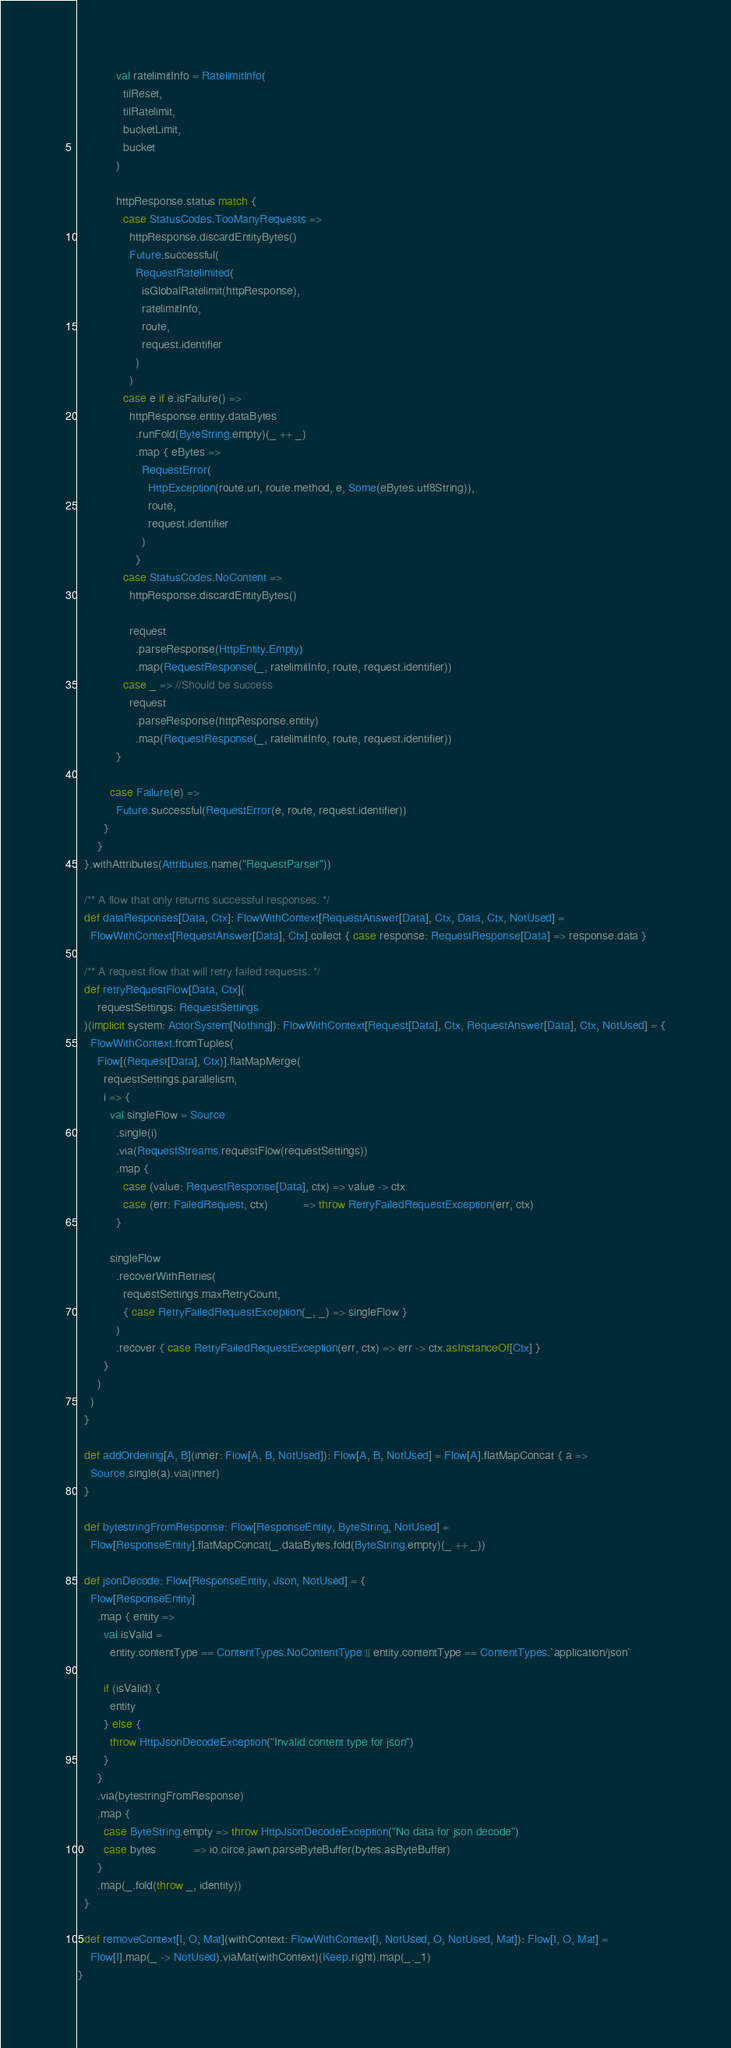<code> <loc_0><loc_0><loc_500><loc_500><_Scala_>
            val ratelimitInfo = RatelimitInfo(
              tilReset,
              tilRatelimit,
              bucketLimit,
              bucket
            )

            httpResponse.status match {
              case StatusCodes.TooManyRequests =>
                httpResponse.discardEntityBytes()
                Future.successful(
                  RequestRatelimited(
                    isGlobalRatelimit(httpResponse),
                    ratelimitInfo,
                    route,
                    request.identifier
                  )
                )
              case e if e.isFailure() =>
                httpResponse.entity.dataBytes
                  .runFold(ByteString.empty)(_ ++ _)
                  .map { eBytes =>
                    RequestError(
                      HttpException(route.uri, route.method, e, Some(eBytes.utf8String)),
                      route,
                      request.identifier
                    )
                  }
              case StatusCodes.NoContent =>
                httpResponse.discardEntityBytes()

                request
                  .parseResponse(HttpEntity.Empty)
                  .map(RequestResponse(_, ratelimitInfo, route, request.identifier))
              case _ => //Should be success
                request
                  .parseResponse(httpResponse.entity)
                  .map(RequestResponse(_, ratelimitInfo, route, request.identifier))
            }

          case Failure(e) =>
            Future.successful(RequestError(e, route, request.identifier))
        }
      }
  }.withAttributes(Attributes.name("RequestParser"))

  /** A flow that only returns successful responses. */
  def dataResponses[Data, Ctx]: FlowWithContext[RequestAnswer[Data], Ctx, Data, Ctx, NotUsed] =
    FlowWithContext[RequestAnswer[Data], Ctx].collect { case response: RequestResponse[Data] => response.data }

  /** A request flow that will retry failed requests. */
  def retryRequestFlow[Data, Ctx](
      requestSettings: RequestSettings
  )(implicit system: ActorSystem[Nothing]): FlowWithContext[Request[Data], Ctx, RequestAnswer[Data], Ctx, NotUsed] = {
    FlowWithContext.fromTuples(
      Flow[(Request[Data], Ctx)].flatMapMerge(
        requestSettings.parallelism,
        i => {
          val singleFlow = Source
            .single(i)
            .via(RequestStreams.requestFlow(requestSettings))
            .map {
              case (value: RequestResponse[Data], ctx) => value -> ctx
              case (err: FailedRequest, ctx)           => throw RetryFailedRequestException(err, ctx)
            }

          singleFlow
            .recoverWithRetries(
              requestSettings.maxRetryCount,
              { case RetryFailedRequestException(_, _) => singleFlow }
            )
            .recover { case RetryFailedRequestException(err, ctx) => err -> ctx.asInstanceOf[Ctx] }
        }
      )
    )
  }

  def addOrdering[A, B](inner: Flow[A, B, NotUsed]): Flow[A, B, NotUsed] = Flow[A].flatMapConcat { a =>
    Source.single(a).via(inner)
  }

  def bytestringFromResponse: Flow[ResponseEntity, ByteString, NotUsed] =
    Flow[ResponseEntity].flatMapConcat(_.dataBytes.fold(ByteString.empty)(_ ++ _))

  def jsonDecode: Flow[ResponseEntity, Json, NotUsed] = {
    Flow[ResponseEntity]
      .map { entity =>
        val isValid =
          entity.contentType == ContentTypes.NoContentType || entity.contentType == ContentTypes.`application/json`

        if (isValid) {
          entity
        } else {
          throw HttpJsonDecodeException("Invalid content type for json")
        }
      }
      .via(bytestringFromResponse)
      .map {
        case ByteString.empty => throw HttpJsonDecodeException("No data for json decode")
        case bytes            => io.circe.jawn.parseByteBuffer(bytes.asByteBuffer)
      }
      .map(_.fold(throw _, identity))
  }

  def removeContext[I, O, Mat](withContext: FlowWithContext[I, NotUsed, O, NotUsed, Mat]): Flow[I, O, Mat] =
    Flow[I].map(_ -> NotUsed).viaMat(withContext)(Keep.right).map(_._1)
}
</code> 